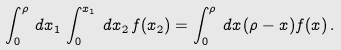<formula> <loc_0><loc_0><loc_500><loc_500>\int _ { 0 } ^ { \rho } \, d x _ { 1 } \, \int _ { 0 } ^ { x _ { 1 } } \, d x _ { 2 } \, f ( x _ { 2 } ) = \int _ { 0 } ^ { \rho } \, d x \, ( \rho - x ) f ( x ) \, .</formula> 